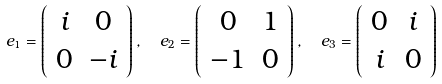Convert formula to latex. <formula><loc_0><loc_0><loc_500><loc_500>e _ { 1 } = \left ( \begin{array} { c c } i & 0 \\ 0 & - i \end{array} \right ) , \ \ e _ { 2 } = \left ( \begin{array} { c c } 0 & 1 \\ - 1 & 0 \end{array} \right ) , \ \ e _ { 3 } = \left ( \begin{array} { c c } 0 & i \\ i & 0 \end{array} \right )</formula> 